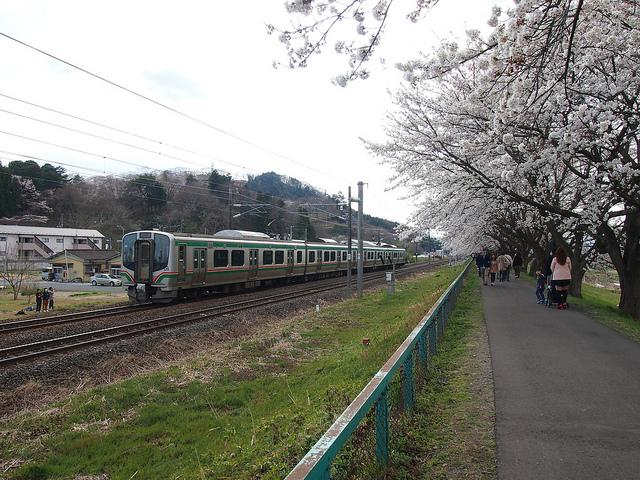What type of socks is the woman pushing the stroller wearing? red 